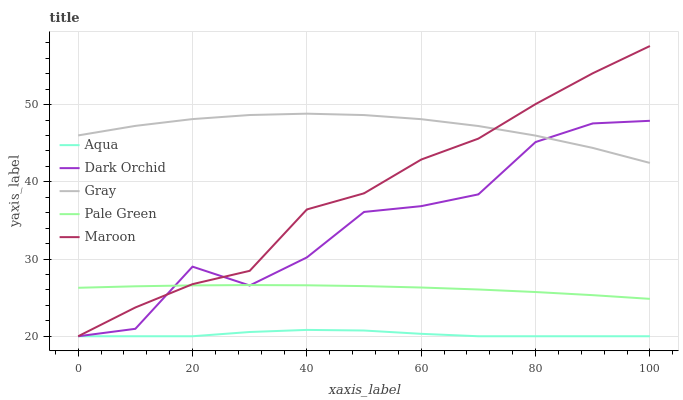Does Aqua have the minimum area under the curve?
Answer yes or no. Yes. Does Gray have the maximum area under the curve?
Answer yes or no. Yes. Does Pale Green have the minimum area under the curve?
Answer yes or no. No. Does Pale Green have the maximum area under the curve?
Answer yes or no. No. Is Pale Green the smoothest?
Answer yes or no. Yes. Is Dark Orchid the roughest?
Answer yes or no. Yes. Is Aqua the smoothest?
Answer yes or no. No. Is Aqua the roughest?
Answer yes or no. No. Does Aqua have the lowest value?
Answer yes or no. Yes. Does Pale Green have the lowest value?
Answer yes or no. No. Does Maroon have the highest value?
Answer yes or no. Yes. Does Pale Green have the highest value?
Answer yes or no. No. Is Aqua less than Pale Green?
Answer yes or no. Yes. Is Gray greater than Aqua?
Answer yes or no. Yes. Does Dark Orchid intersect Gray?
Answer yes or no. Yes. Is Dark Orchid less than Gray?
Answer yes or no. No. Is Dark Orchid greater than Gray?
Answer yes or no. No. Does Aqua intersect Pale Green?
Answer yes or no. No. 